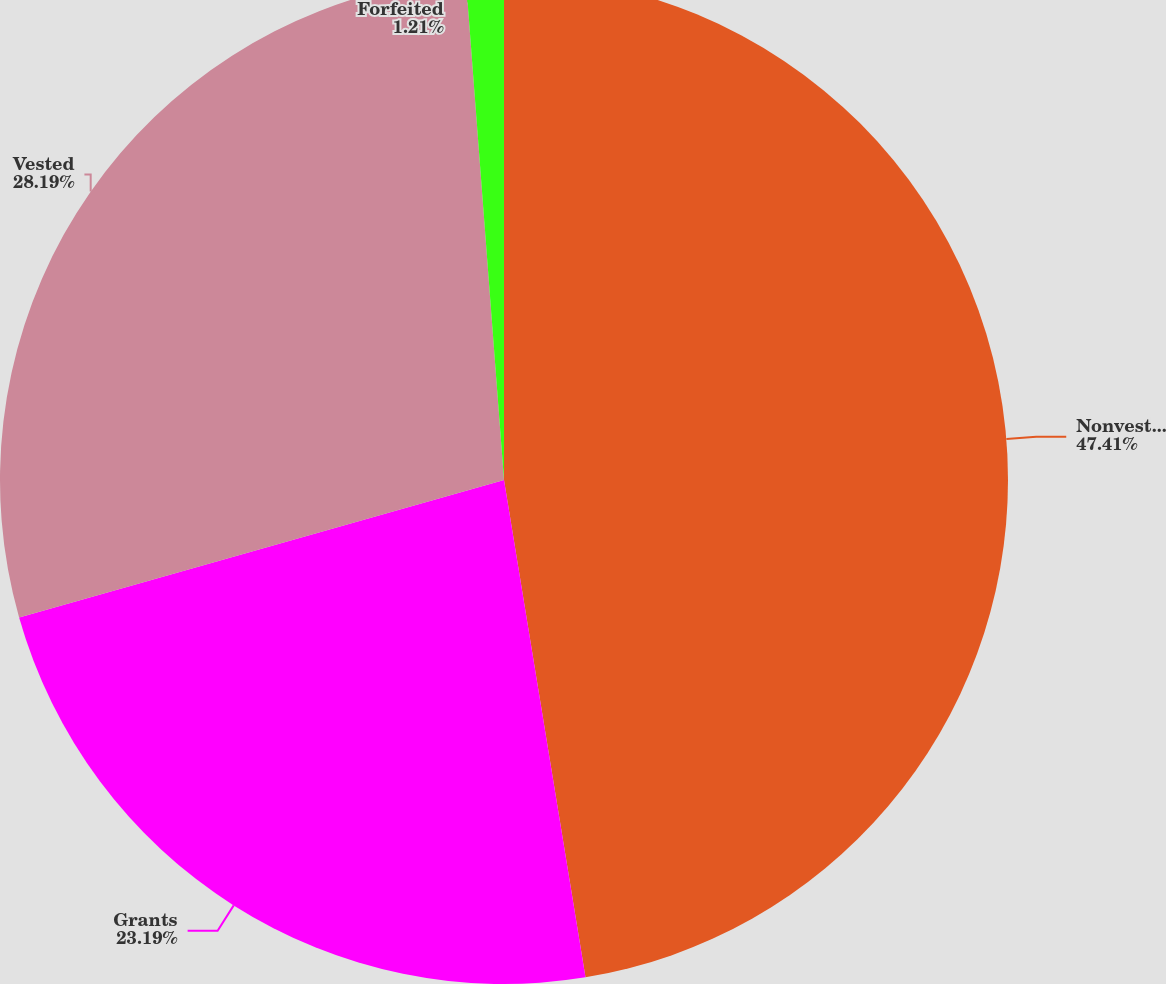<chart> <loc_0><loc_0><loc_500><loc_500><pie_chart><fcel>Nonvested restricted shares at<fcel>Grants<fcel>Vested<fcel>Forfeited<nl><fcel>47.42%<fcel>23.19%<fcel>28.19%<fcel>1.21%<nl></chart> 